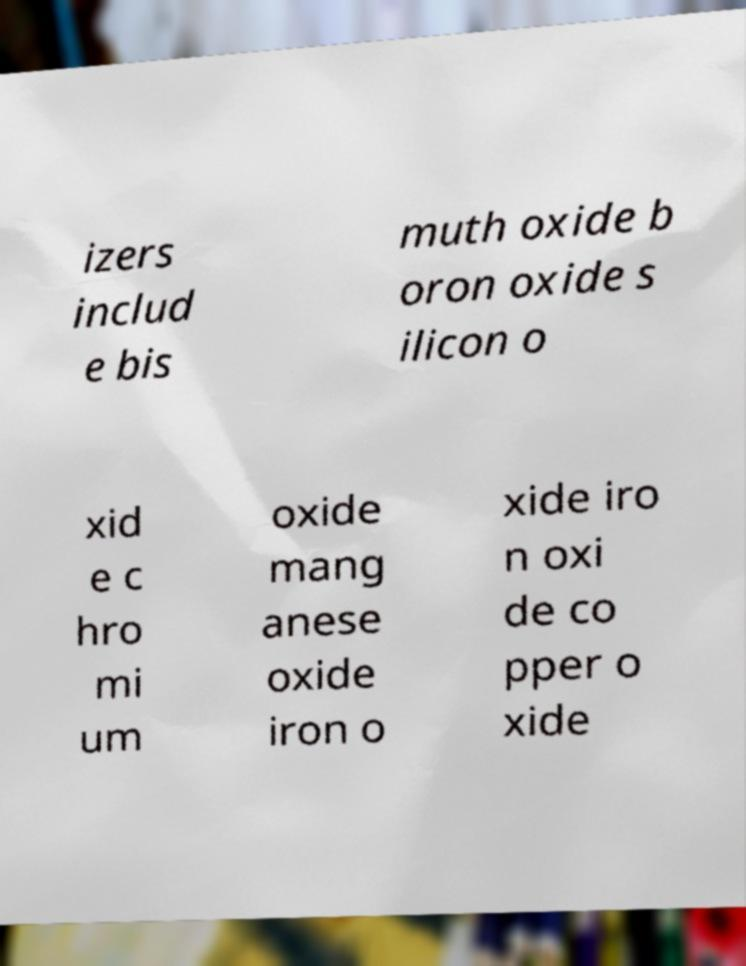Please read and relay the text visible in this image. What does it say? izers includ e bis muth oxide b oron oxide s ilicon o xid e c hro mi um oxide mang anese oxide iron o xide iro n oxi de co pper o xide 